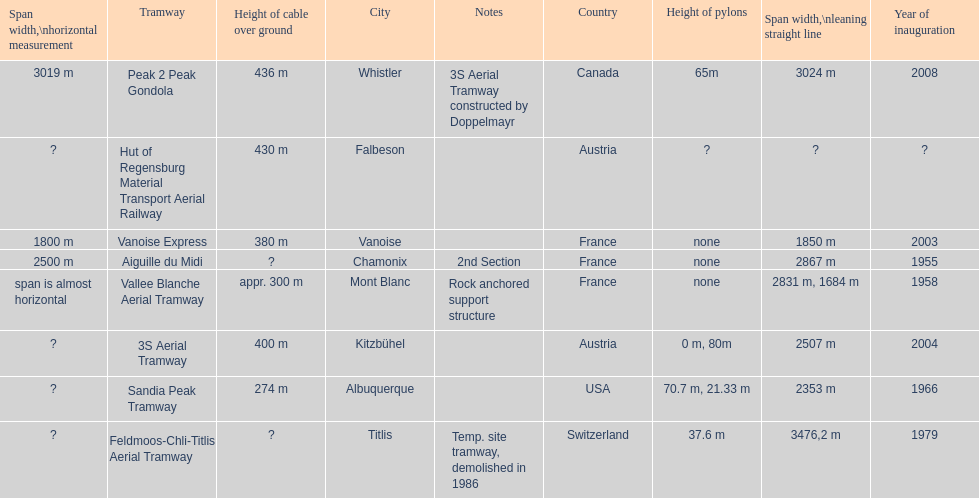Which tramway was built directly before the 3s aeriral tramway? Vanoise Express. 